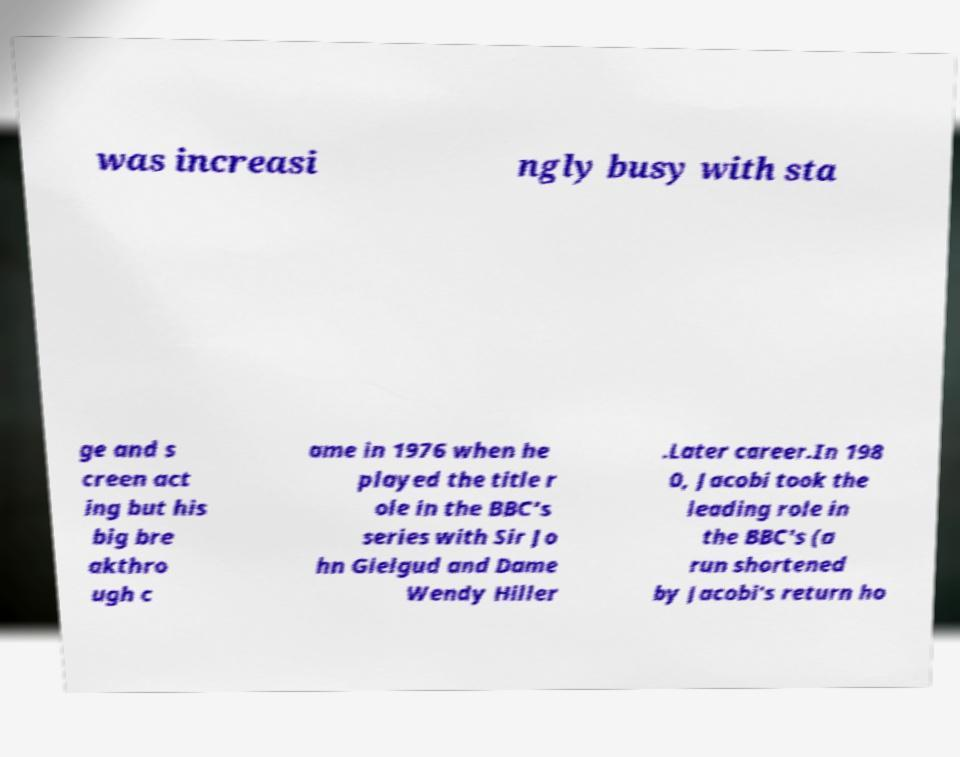What messages or text are displayed in this image? I need them in a readable, typed format. was increasi ngly busy with sta ge and s creen act ing but his big bre akthro ugh c ame in 1976 when he played the title r ole in the BBC's series with Sir Jo hn Gielgud and Dame Wendy Hiller .Later career.In 198 0, Jacobi took the leading role in the BBC's (a run shortened by Jacobi's return ho 